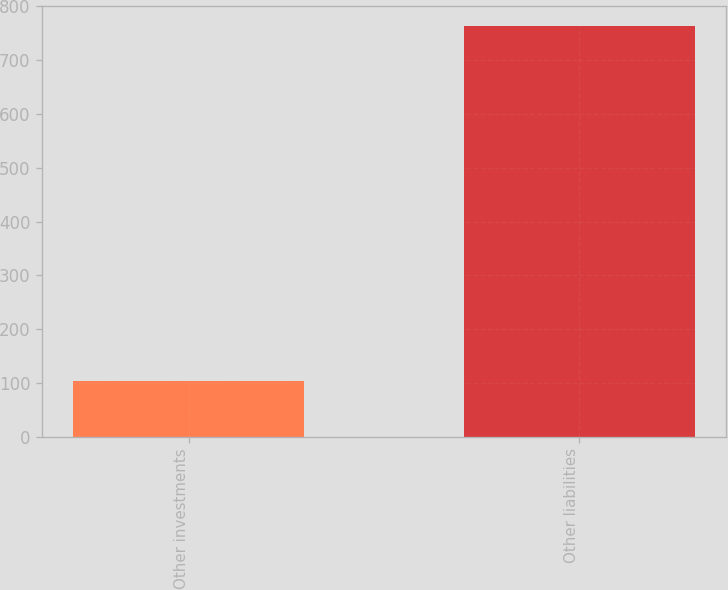Convert chart. <chart><loc_0><loc_0><loc_500><loc_500><bar_chart><fcel>Other investments<fcel>Other liabilities<nl><fcel>103<fcel>763<nl></chart> 